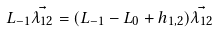<formula> <loc_0><loc_0><loc_500><loc_500>L _ { - 1 } \vec { \lambda _ { 1 2 } } = ( L _ { - 1 } - L _ { 0 } + h _ { 1 , 2 } ) \vec { \lambda _ { 1 2 } }</formula> 